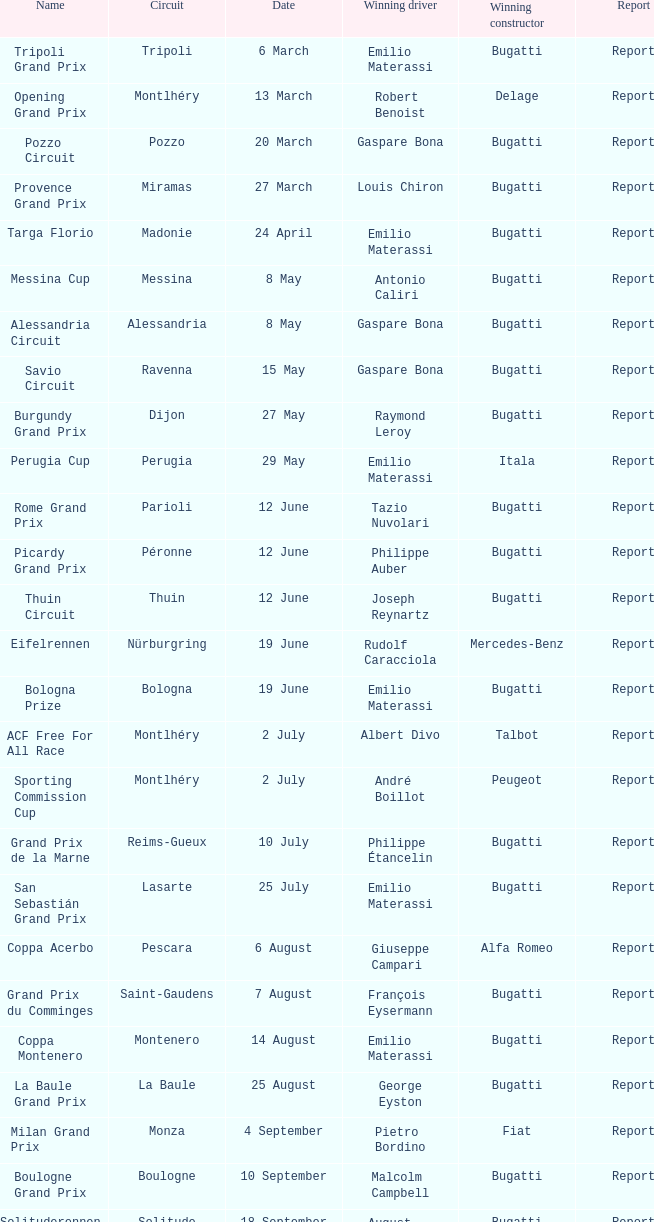When did gaspare bona achieve victory in the pozzo circuit? 20 March. 